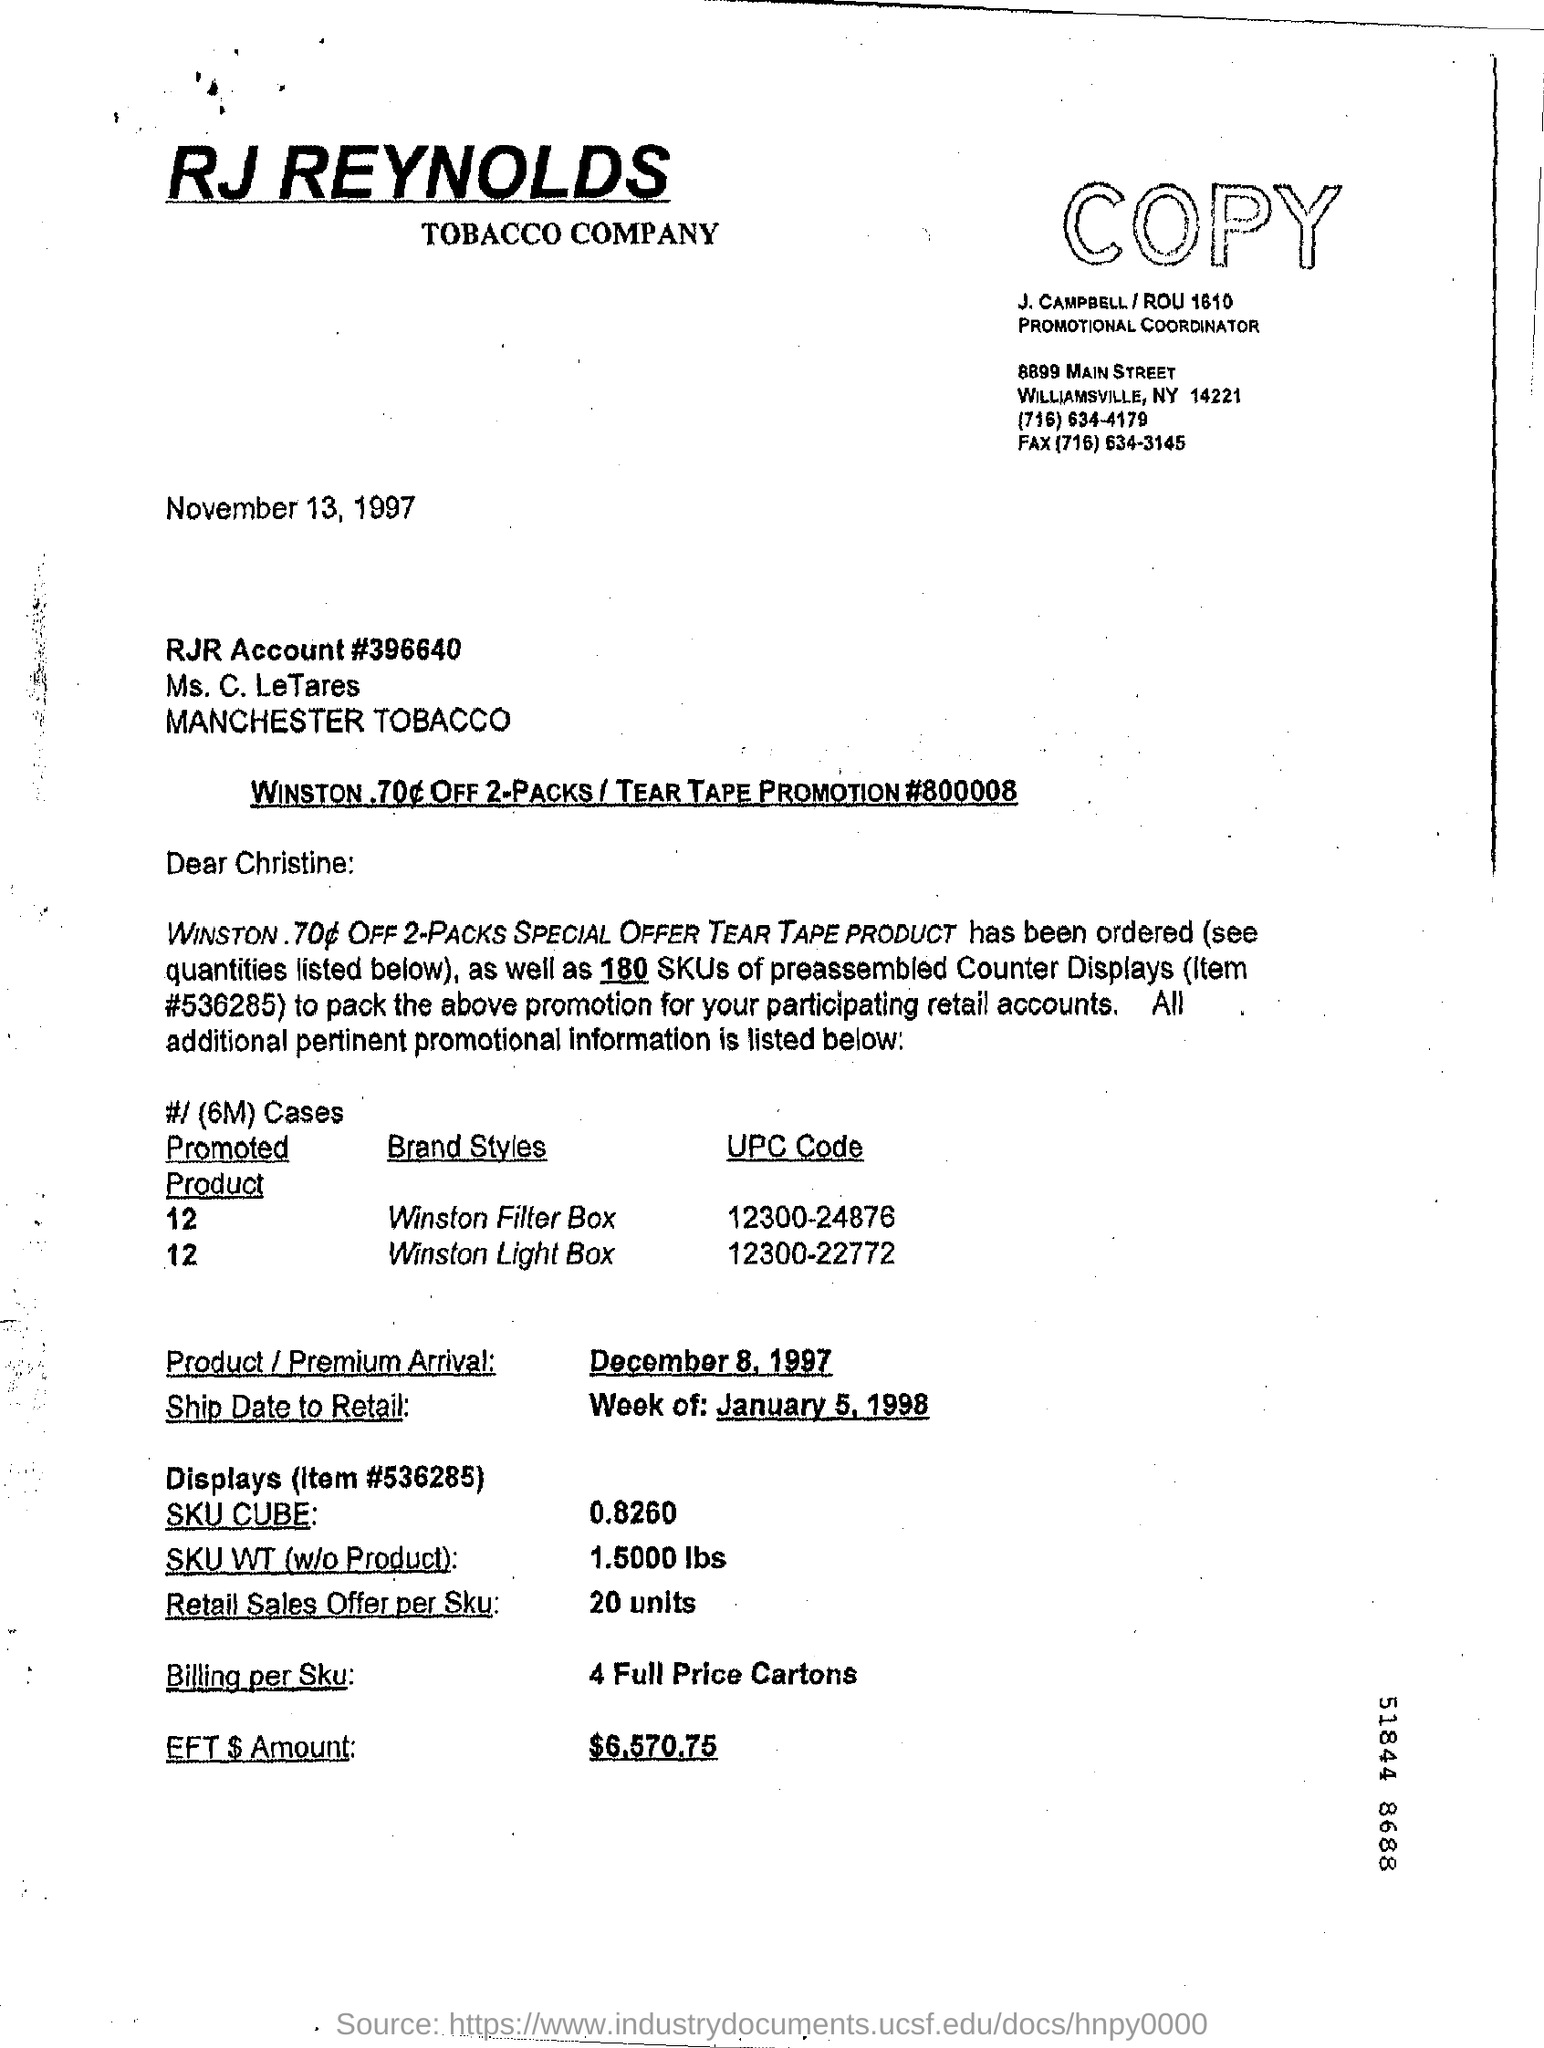What can you infer about the promotion mentioned in the document? The document outlines a promotional offer that includes a discount on two-pack Winston cigarette products. The use of 'Tear Tape' implies that there might be a physical tape or coupon on the pack that customers can tear off to receive a 70 cent discount. The promotion was meticulously planned, with details such as product codes, ship dates, and sales offers. It indicates a structured approach to marketing and distributing tobacco products at the time. What does 'SKU CUBE' refer to? 'SKU CUBE' refers to the cubic dimension or volume taken up by the Stock Keeping Unit (SKU), which is a measure of how much space a batch of products would occupy. In this case, the SKU CUBE is 0.8260, likely referring to cubic feet or another volumetric measurement which is crucial for logistical planning such as storage and transportation. 